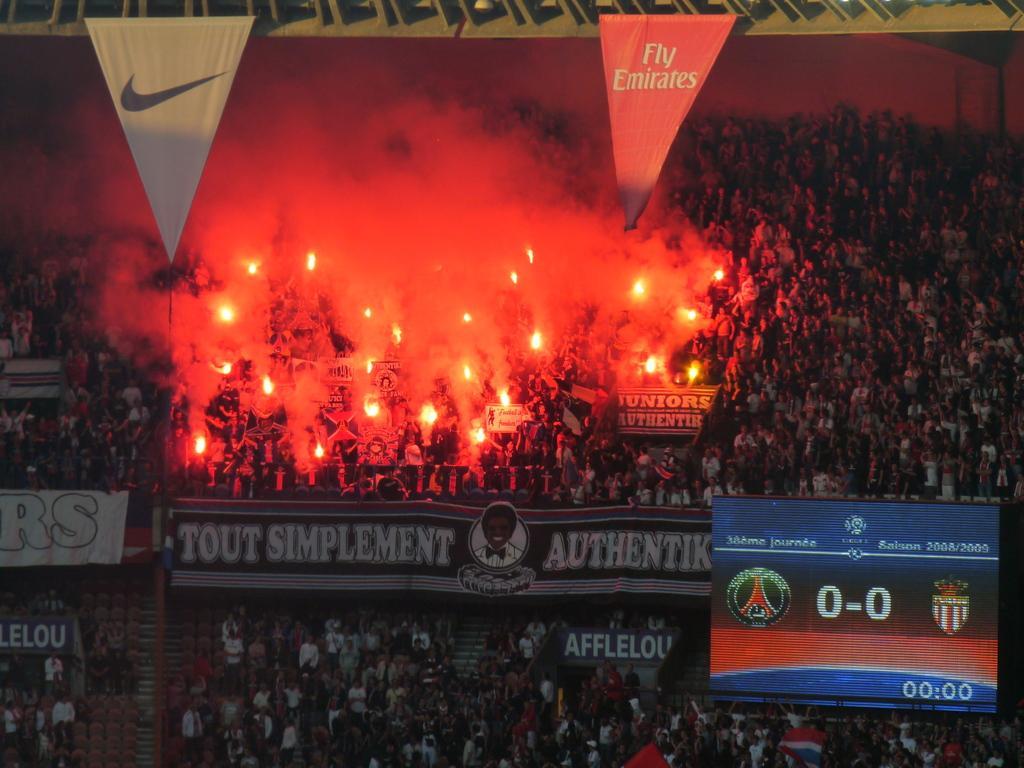Could you give a brief overview of what you see in this image? This image is clicked in a stadium. There are many people standing. In the center there are boards with text. In the bottom right there is a display screen. At the top there are people holding fire lamps. 